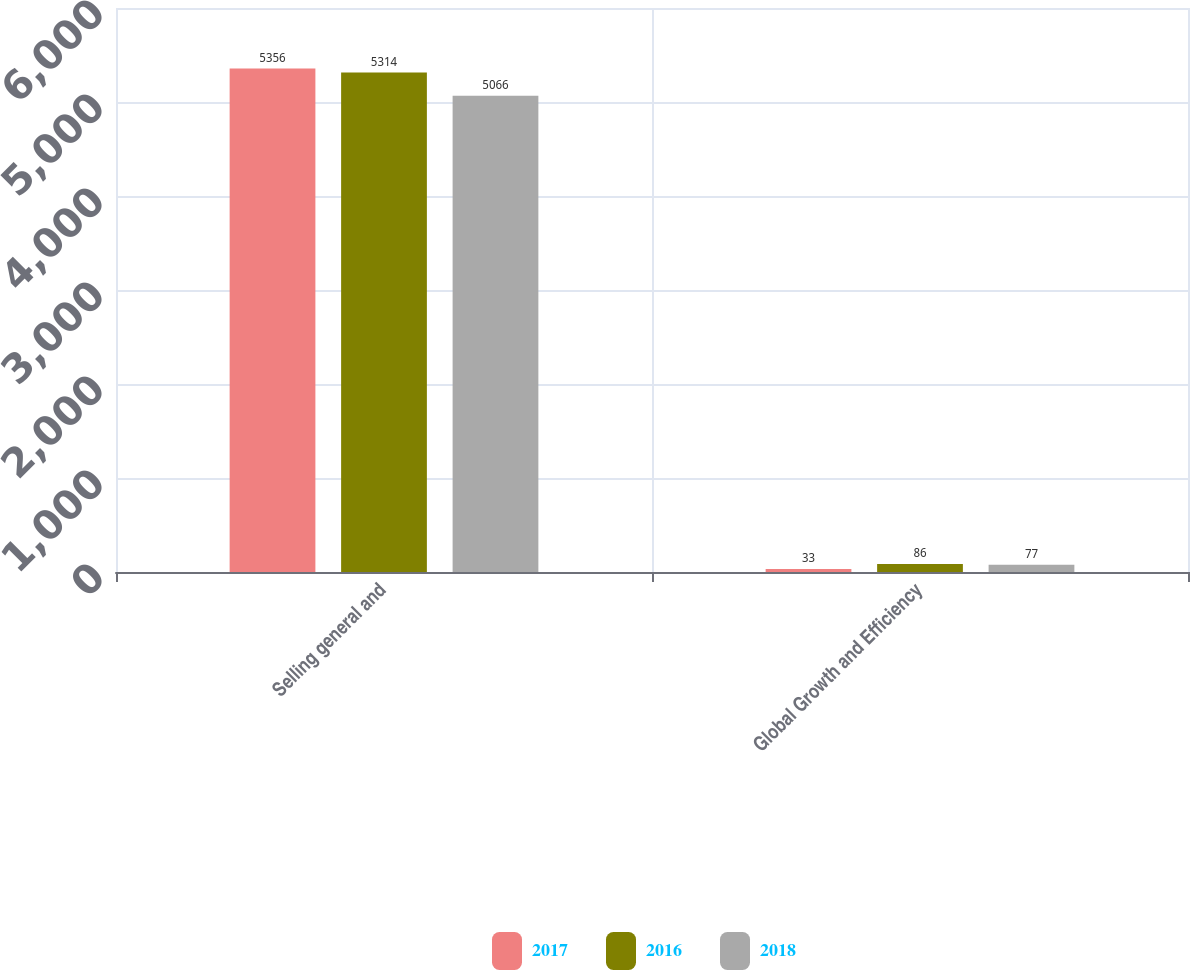Convert chart. <chart><loc_0><loc_0><loc_500><loc_500><stacked_bar_chart><ecel><fcel>Selling general and<fcel>Global Growth and Efficiency<nl><fcel>2017<fcel>5356<fcel>33<nl><fcel>2016<fcel>5314<fcel>86<nl><fcel>2018<fcel>5066<fcel>77<nl></chart> 